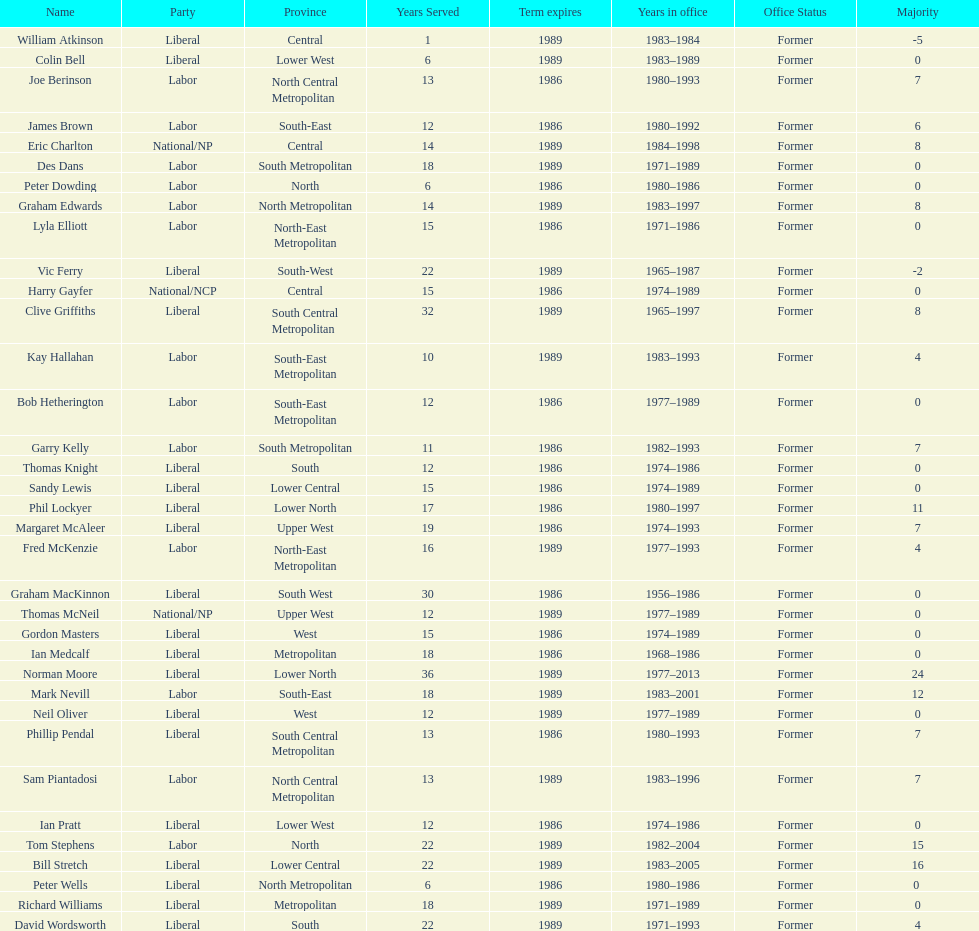What was phil lockyer's party? Liberal. 